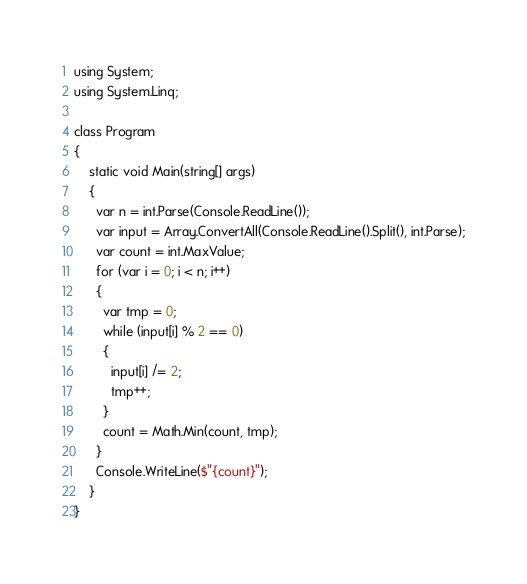<code> <loc_0><loc_0><loc_500><loc_500><_C#_>using System;
using System.Linq;

class Program
{
	static void Main(string[] args)
	{
      var n = int.Parse(Console.ReadLine());
      var input = Array.ConvertAll(Console.ReadLine().Split(), int.Parse);
	  var count = int.MaxValue;
	  for (var i = 0; i < n; i++)
      {
        var tmp = 0;
        while (input[i] % 2 == 0)
        {
          input[i] /= 2;
          tmp++;
        }
        count = Math.Min(count, tmp);
      }   
      Console.WriteLine($"{count}");
	}
}
</code> 